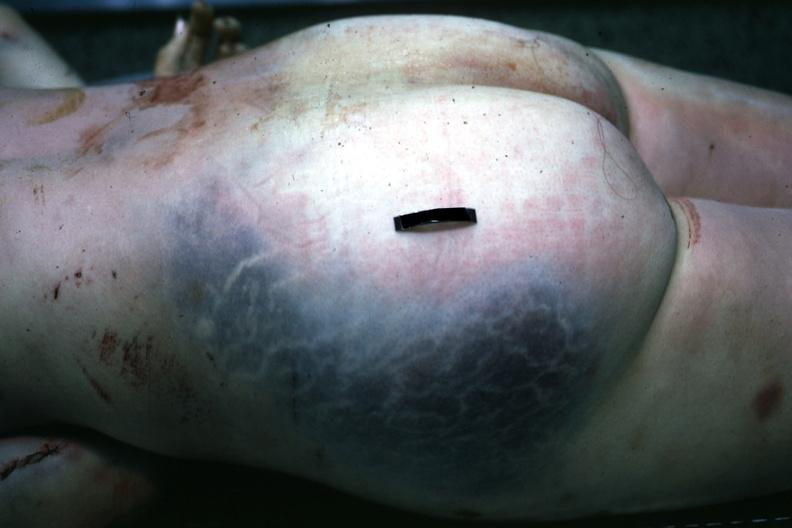what is present?
Answer the question using a single word or phrase. Muscle 